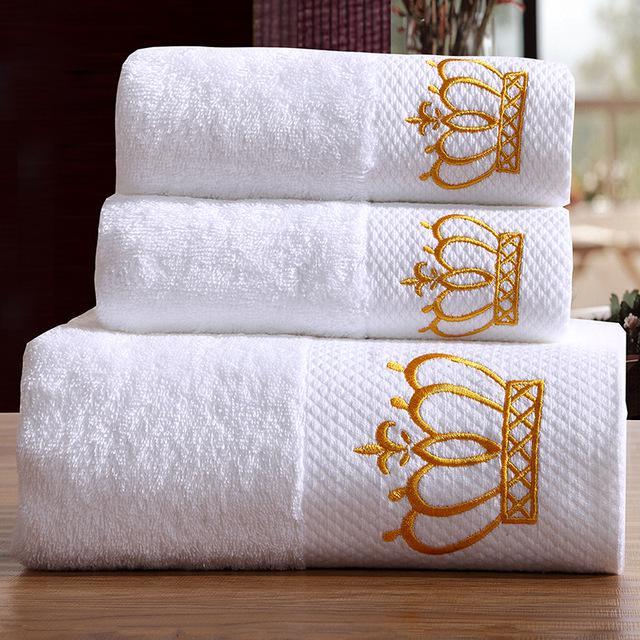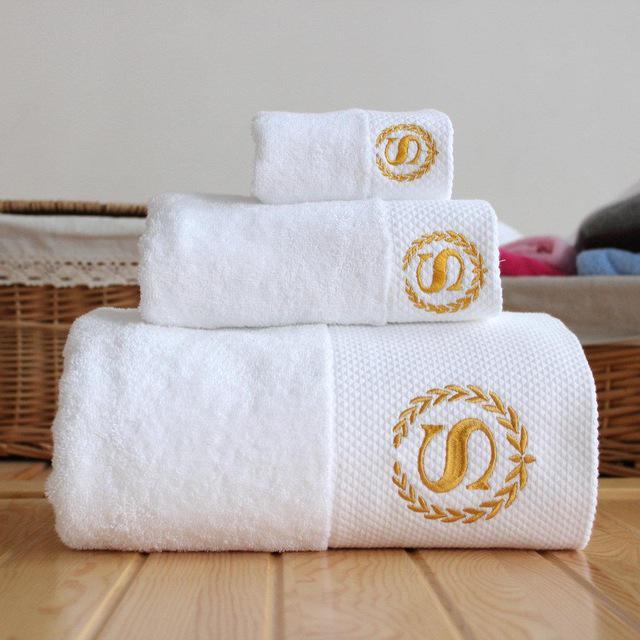The first image is the image on the left, the second image is the image on the right. Considering the images on both sides, is "The left image shows three white towels with the Sheraton logo stacked on top of each other." valid? Answer yes or no. Yes. The first image is the image on the left, the second image is the image on the right. Assess this claim about the two images: "In one of the images, four towels are stacked in a single stack.". Correct or not? Answer yes or no. No. 